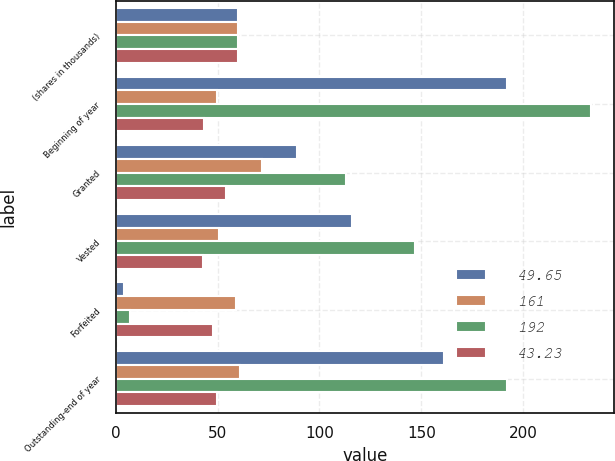Convert chart to OTSL. <chart><loc_0><loc_0><loc_500><loc_500><stacked_bar_chart><ecel><fcel>(shares in thousands)<fcel>Beginning of year<fcel>Granted<fcel>Vested<fcel>Forfeited<fcel>Outstanding-end of year<nl><fcel>49.65<fcel>60.055<fcel>192<fcel>89<fcel>116<fcel>4<fcel>161<nl><fcel>161<fcel>60.055<fcel>49.65<fcel>71.6<fcel>50.91<fcel>59.25<fcel>60.86<nl><fcel>192<fcel>60.055<fcel>233<fcel>113<fcel>147<fcel>7<fcel>192<nl><fcel>43.23<fcel>60.055<fcel>43.23<fcel>54.3<fcel>42.82<fcel>47.88<fcel>49.65<nl></chart> 